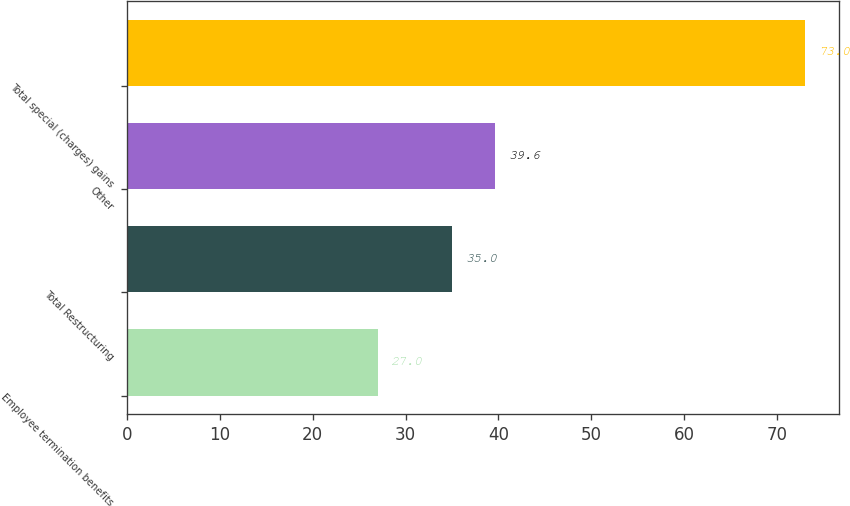Convert chart to OTSL. <chart><loc_0><loc_0><loc_500><loc_500><bar_chart><fcel>Employee termination benefits<fcel>Total Restructuring<fcel>Other<fcel>Total special (charges) gains<nl><fcel>27<fcel>35<fcel>39.6<fcel>73<nl></chart> 